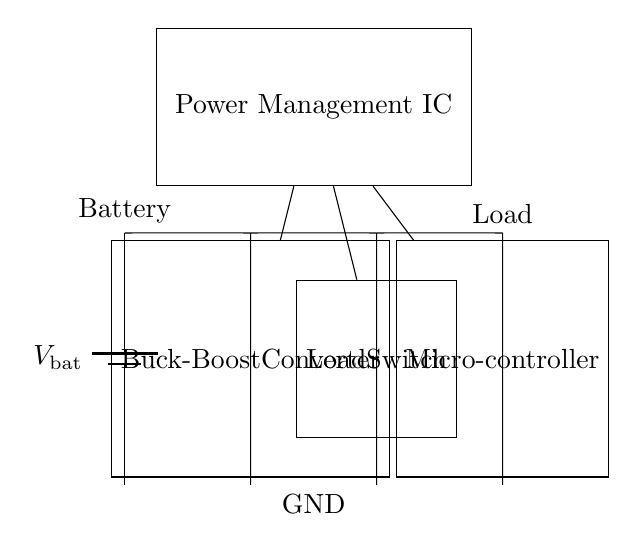What is the primary function of the Buck-Boost Converter? The Buck-Boost Converter in the circuit is designed to regulate voltage by stepping up or stepping down the voltage from the battery to maintain a stable output voltage.
Answer: Regulate voltage What component connects to the Load Switch? The Load Switch is connected to the Microcontroller as well as the output from the Buck-Boost Converter, which allows it to control whether the load receives power.
Answer: Microcontroller How many main components are in this circuit? The circuit contains four main components: the Battery, Buck-Boost Converter, Load Switch, and Microcontroller.
Answer: Four What does the Power Management IC do? The Power Management IC serves to manage the distribution of power from the battery through the Buck-Boost Converter and Load Switch to the Microcontroller, optimizing battery usage and efficiency.
Answer: Manage power Which component is responsible for maintaining extended battery life? The combination of the Buck-Boost Converter and the Power Management IC are responsible for maintaining extended battery life by efficiently managing the power delivered to the load.
Answer: Buck-Boost Converter and Power Management IC What is the voltage source in this circuit? The voltage source in the circuit is the Battery, which provides the initial power supply to the Buck-Boost Converter and the rest of the circuit.
Answer: Battery 